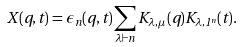Convert formula to latex. <formula><loc_0><loc_0><loc_500><loc_500>X ( q , t ) = \epsilon _ { n } ( q , t ) \sum _ { \lambda \vdash n } K _ { \lambda , \mu } ( q ) K _ { \lambda , 1 ^ { n } } ( t ) .</formula> 